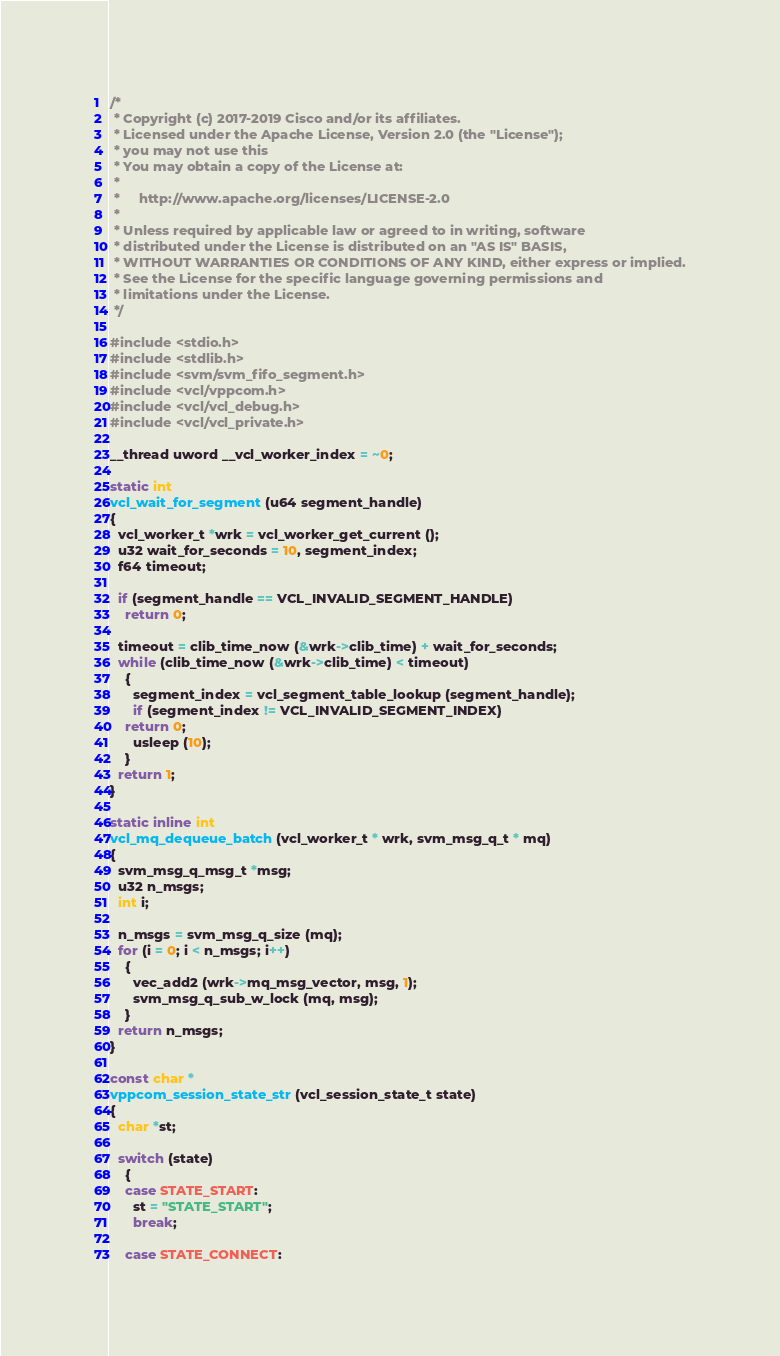<code> <loc_0><loc_0><loc_500><loc_500><_C_>/*
 * Copyright (c) 2017-2019 Cisco and/or its affiliates.
 * Licensed under the Apache License, Version 2.0 (the "License");
 * you may not use this
 * You may obtain a copy of the License at:
 *
 *     http://www.apache.org/licenses/LICENSE-2.0
 *
 * Unless required by applicable law or agreed to in writing, software
 * distributed under the License is distributed on an "AS IS" BASIS,
 * WITHOUT WARRANTIES OR CONDITIONS OF ANY KIND, either express or implied.
 * See the License for the specific language governing permissions and
 * limitations under the License.
 */

#include <stdio.h>
#include <stdlib.h>
#include <svm/svm_fifo_segment.h>
#include <vcl/vppcom.h>
#include <vcl/vcl_debug.h>
#include <vcl/vcl_private.h>

__thread uword __vcl_worker_index = ~0;

static int
vcl_wait_for_segment (u64 segment_handle)
{
  vcl_worker_t *wrk = vcl_worker_get_current ();
  u32 wait_for_seconds = 10, segment_index;
  f64 timeout;

  if (segment_handle == VCL_INVALID_SEGMENT_HANDLE)
    return 0;

  timeout = clib_time_now (&wrk->clib_time) + wait_for_seconds;
  while (clib_time_now (&wrk->clib_time) < timeout)
    {
      segment_index = vcl_segment_table_lookup (segment_handle);
      if (segment_index != VCL_INVALID_SEGMENT_INDEX)
	return 0;
      usleep (10);
    }
  return 1;
}

static inline int
vcl_mq_dequeue_batch (vcl_worker_t * wrk, svm_msg_q_t * mq)
{
  svm_msg_q_msg_t *msg;
  u32 n_msgs;
  int i;

  n_msgs = svm_msg_q_size (mq);
  for (i = 0; i < n_msgs; i++)
    {
      vec_add2 (wrk->mq_msg_vector, msg, 1);
      svm_msg_q_sub_w_lock (mq, msg);
    }
  return n_msgs;
}

const char *
vppcom_session_state_str (vcl_session_state_t state)
{
  char *st;

  switch (state)
    {
    case STATE_START:
      st = "STATE_START";
      break;

    case STATE_CONNECT:</code> 